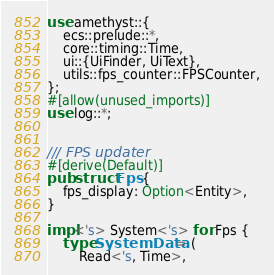Convert code to text. <code><loc_0><loc_0><loc_500><loc_500><_Rust_>use amethyst::{
    ecs::prelude::*,
    core::timing::Time,
    ui::{UiFinder, UiText},
    utils::fps_counter::FPSCounter,
};
#[allow(unused_imports)]
use log::*;


/// FPS updater
#[derive(Default)]
pub struct Fps {
    fps_display: Option<Entity>,
}

impl<'s> System<'s> for Fps {
    type SystemData = (
        Read<'s, Time>,</code> 